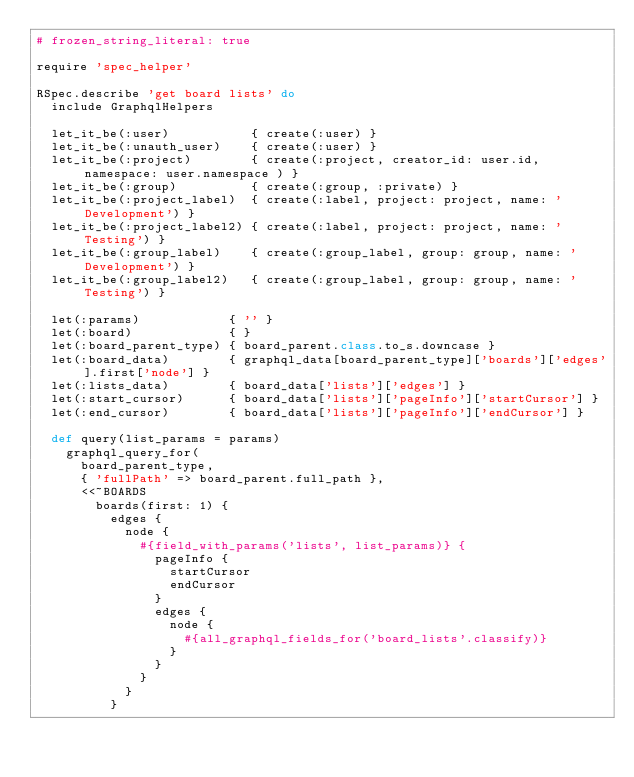Convert code to text. <code><loc_0><loc_0><loc_500><loc_500><_Ruby_># frozen_string_literal: true

require 'spec_helper'

RSpec.describe 'get board lists' do
  include GraphqlHelpers

  let_it_be(:user)           { create(:user) }
  let_it_be(:unauth_user)    { create(:user) }
  let_it_be(:project)        { create(:project, creator_id: user.id, namespace: user.namespace ) }
  let_it_be(:group)          { create(:group, :private) }
  let_it_be(:project_label)  { create(:label, project: project, name: 'Development') }
  let_it_be(:project_label2) { create(:label, project: project, name: 'Testing') }
  let_it_be(:group_label)    { create(:group_label, group: group, name: 'Development') }
  let_it_be(:group_label2)   { create(:group_label, group: group, name: 'Testing') }

  let(:params)            { '' }
  let(:board)             { }
  let(:board_parent_type) { board_parent.class.to_s.downcase }
  let(:board_data)        { graphql_data[board_parent_type]['boards']['edges'].first['node'] }
  let(:lists_data)        { board_data['lists']['edges'] }
  let(:start_cursor)      { board_data['lists']['pageInfo']['startCursor'] }
  let(:end_cursor)        { board_data['lists']['pageInfo']['endCursor'] }

  def query(list_params = params)
    graphql_query_for(
      board_parent_type,
      { 'fullPath' => board_parent.full_path },
      <<~BOARDS
        boards(first: 1) {
          edges {
            node {
              #{field_with_params('lists', list_params)} {
                pageInfo {
                  startCursor
                  endCursor
                }
                edges {
                  node {
                    #{all_graphql_fields_for('board_lists'.classify)}
                  }
                }
              }
            }
          }</code> 